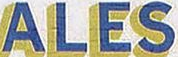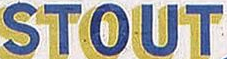Read the text from these images in sequence, separated by a semicolon. ALES; STOUT 